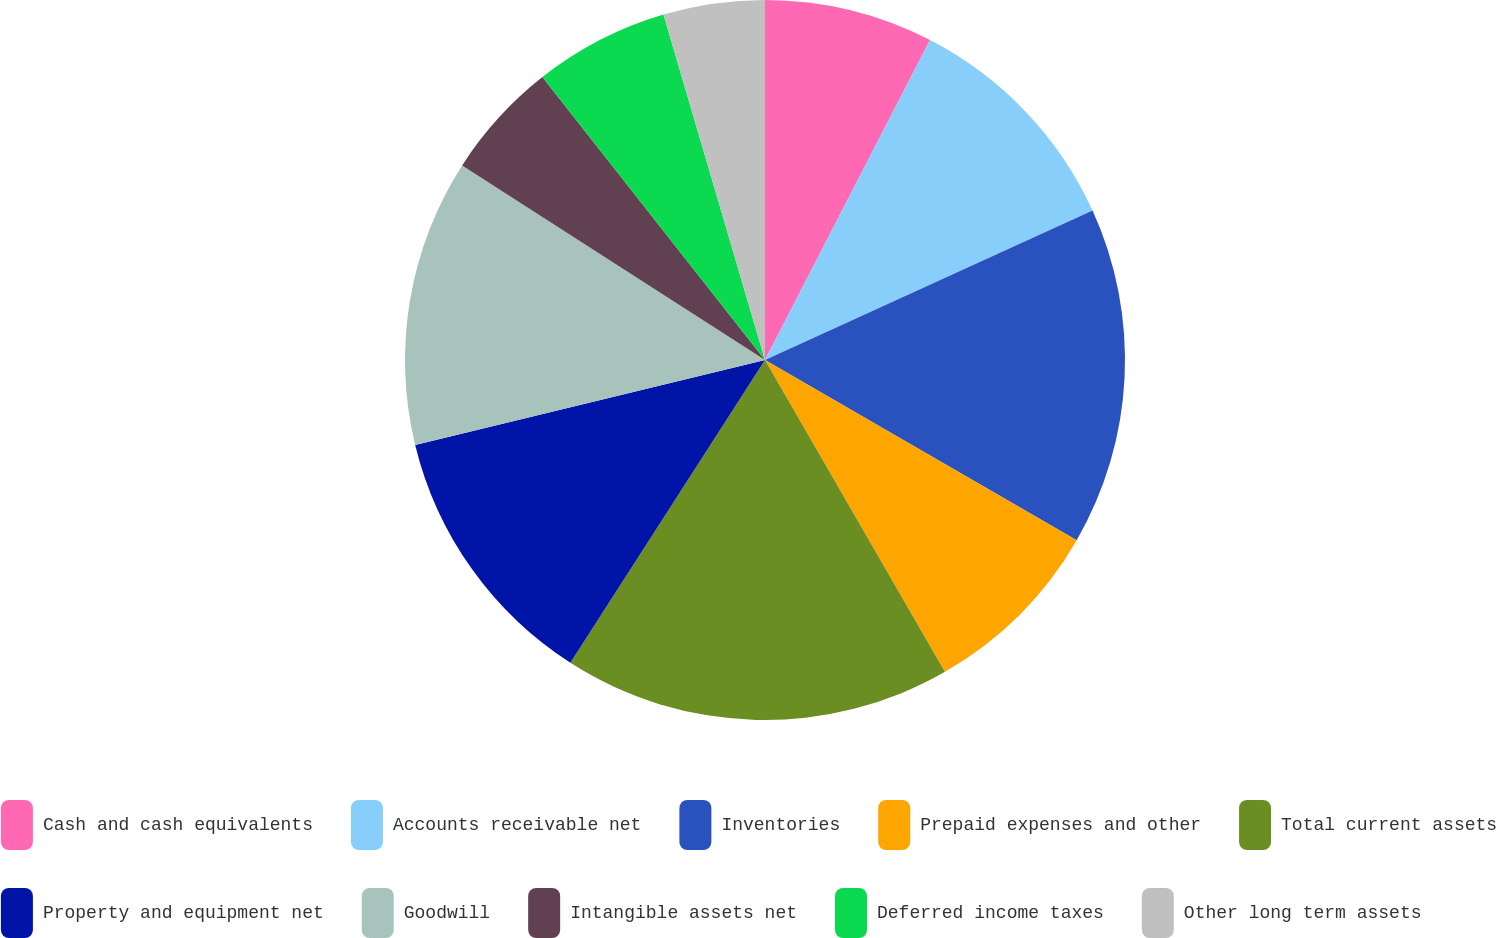Convert chart to OTSL. <chart><loc_0><loc_0><loc_500><loc_500><pie_chart><fcel>Cash and cash equivalents<fcel>Accounts receivable net<fcel>Inventories<fcel>Prepaid expenses and other<fcel>Total current assets<fcel>Property and equipment net<fcel>Goodwill<fcel>Intangible assets net<fcel>Deferred income taxes<fcel>Other long term assets<nl><fcel>7.58%<fcel>10.61%<fcel>15.15%<fcel>8.33%<fcel>17.42%<fcel>12.12%<fcel>12.88%<fcel>5.3%<fcel>6.06%<fcel>4.55%<nl></chart> 